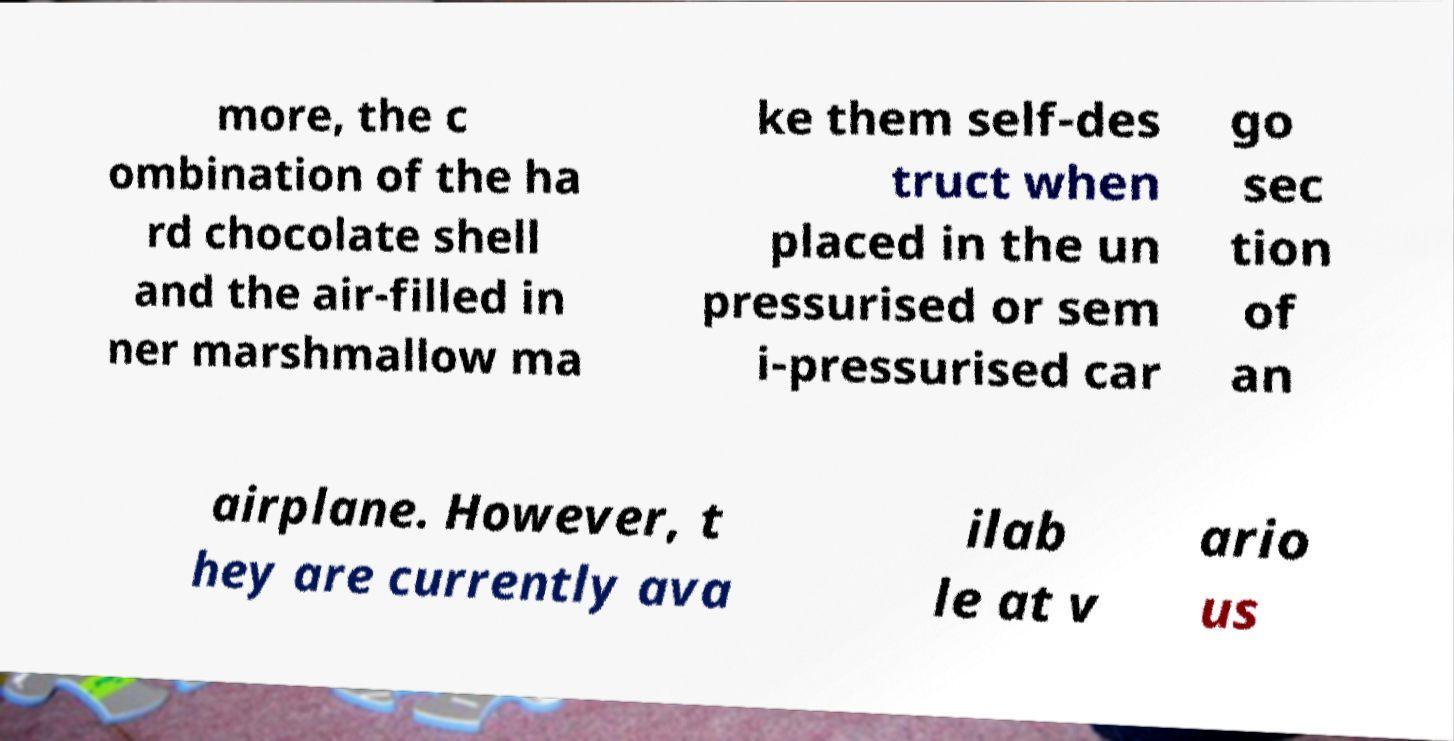I need the written content from this picture converted into text. Can you do that? more, the c ombination of the ha rd chocolate shell and the air-filled in ner marshmallow ma ke them self-des truct when placed in the un pressurised or sem i-pressurised car go sec tion of an airplane. However, t hey are currently ava ilab le at v ario us 